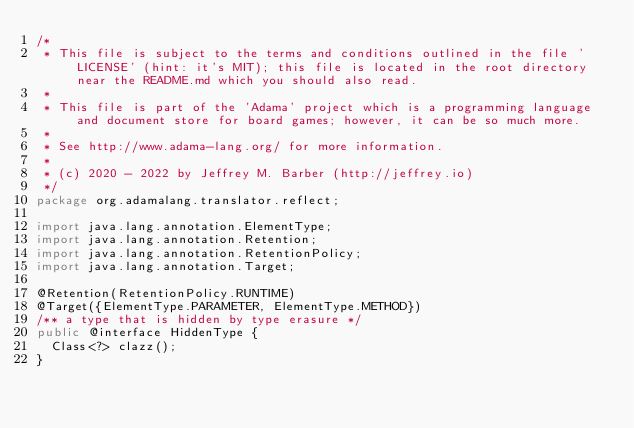<code> <loc_0><loc_0><loc_500><loc_500><_Java_>/*
 * This file is subject to the terms and conditions outlined in the file 'LICENSE' (hint: it's MIT); this file is located in the root directory near the README.md which you should also read.
 *
 * This file is part of the 'Adama' project which is a programming language and document store for board games; however, it can be so much more.
 *
 * See http://www.adama-lang.org/ for more information.
 *
 * (c) 2020 - 2022 by Jeffrey M. Barber (http://jeffrey.io)
 */
package org.adamalang.translator.reflect;

import java.lang.annotation.ElementType;
import java.lang.annotation.Retention;
import java.lang.annotation.RetentionPolicy;
import java.lang.annotation.Target;

@Retention(RetentionPolicy.RUNTIME)
@Target({ElementType.PARAMETER, ElementType.METHOD})
/** a type that is hidden by type erasure */
public @interface HiddenType {
  Class<?> clazz();
}
</code> 